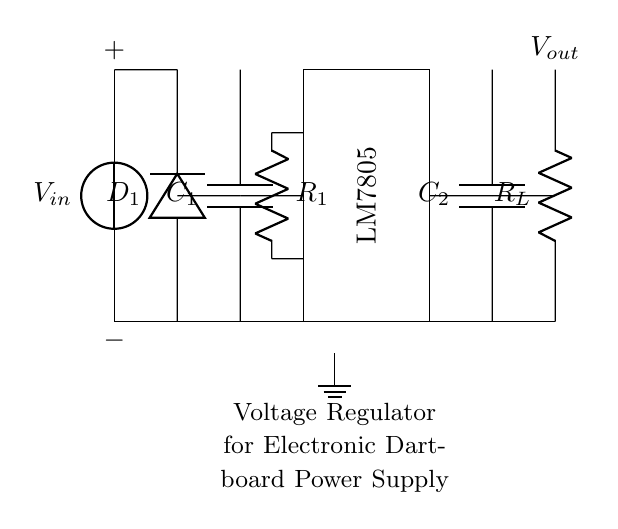What is the input voltage in the circuit? The circuit has an input voltage denoted as Vin, which represents the voltage supplied to the circuit. The diagram does not specify a particular value, just the label, so we refer to it generally as Vin.
Answer: Vin What type of voltage regulator is used? The circuit employs an LM7805 voltage regulator, which is indicated within the rectangle labeled as such. This type of regulator provides a fixed output voltage, primarily at five volts in its standard configuration.
Answer: LM7805 What are the roles of the capacitors in the circuit? The circuit contains two capacitors, C1 and C2, which are typically used for filtering and stabilization. C1 is placed on the input side, often serving to smooth the rectified voltage, while C2 is usually employed at the output to ensure stability and responsiveness of the voltage regulator.
Answer: Filtering and stabilization What is the purpose of the diode in the circuit? The diode, labeled D1, acts as a rectifier in this circuit. It allows current to flow in one direction, converting the alternating current (AC) to direct current (DC), which is necessary for the proper operation of the voltage regulator and connected components.
Answer: Rectification What is the output voltage of this regulator circuit? The LM7805 voltage regulator is designed to output a consistent voltage of five volts, indicated by the labeling on the output terminal Vout. This is the intended operating voltage for the electronic dartboard power supply.
Answer: 5V What is the significance of the load resistor in the circuit? The load resistor, labeled RL, represents the device being powered by the circuit. Its value determines the current drawn from the voltage regulator and impacts the performance of the electronic dartboard, ensuring it receives the necessary voltage and current for proper function.
Answer: Current determination What would happen if C1 were removed from the circuit? Removing C1 would eliminate the filtering effect on the rectified voltage. Without C1, the capacitor that smooths out the fluctuations in the voltage signal would be absent, possibly resulting in a noisy input to the LM7805, which could lead to unstable output voltage.
Answer: Unstable output 